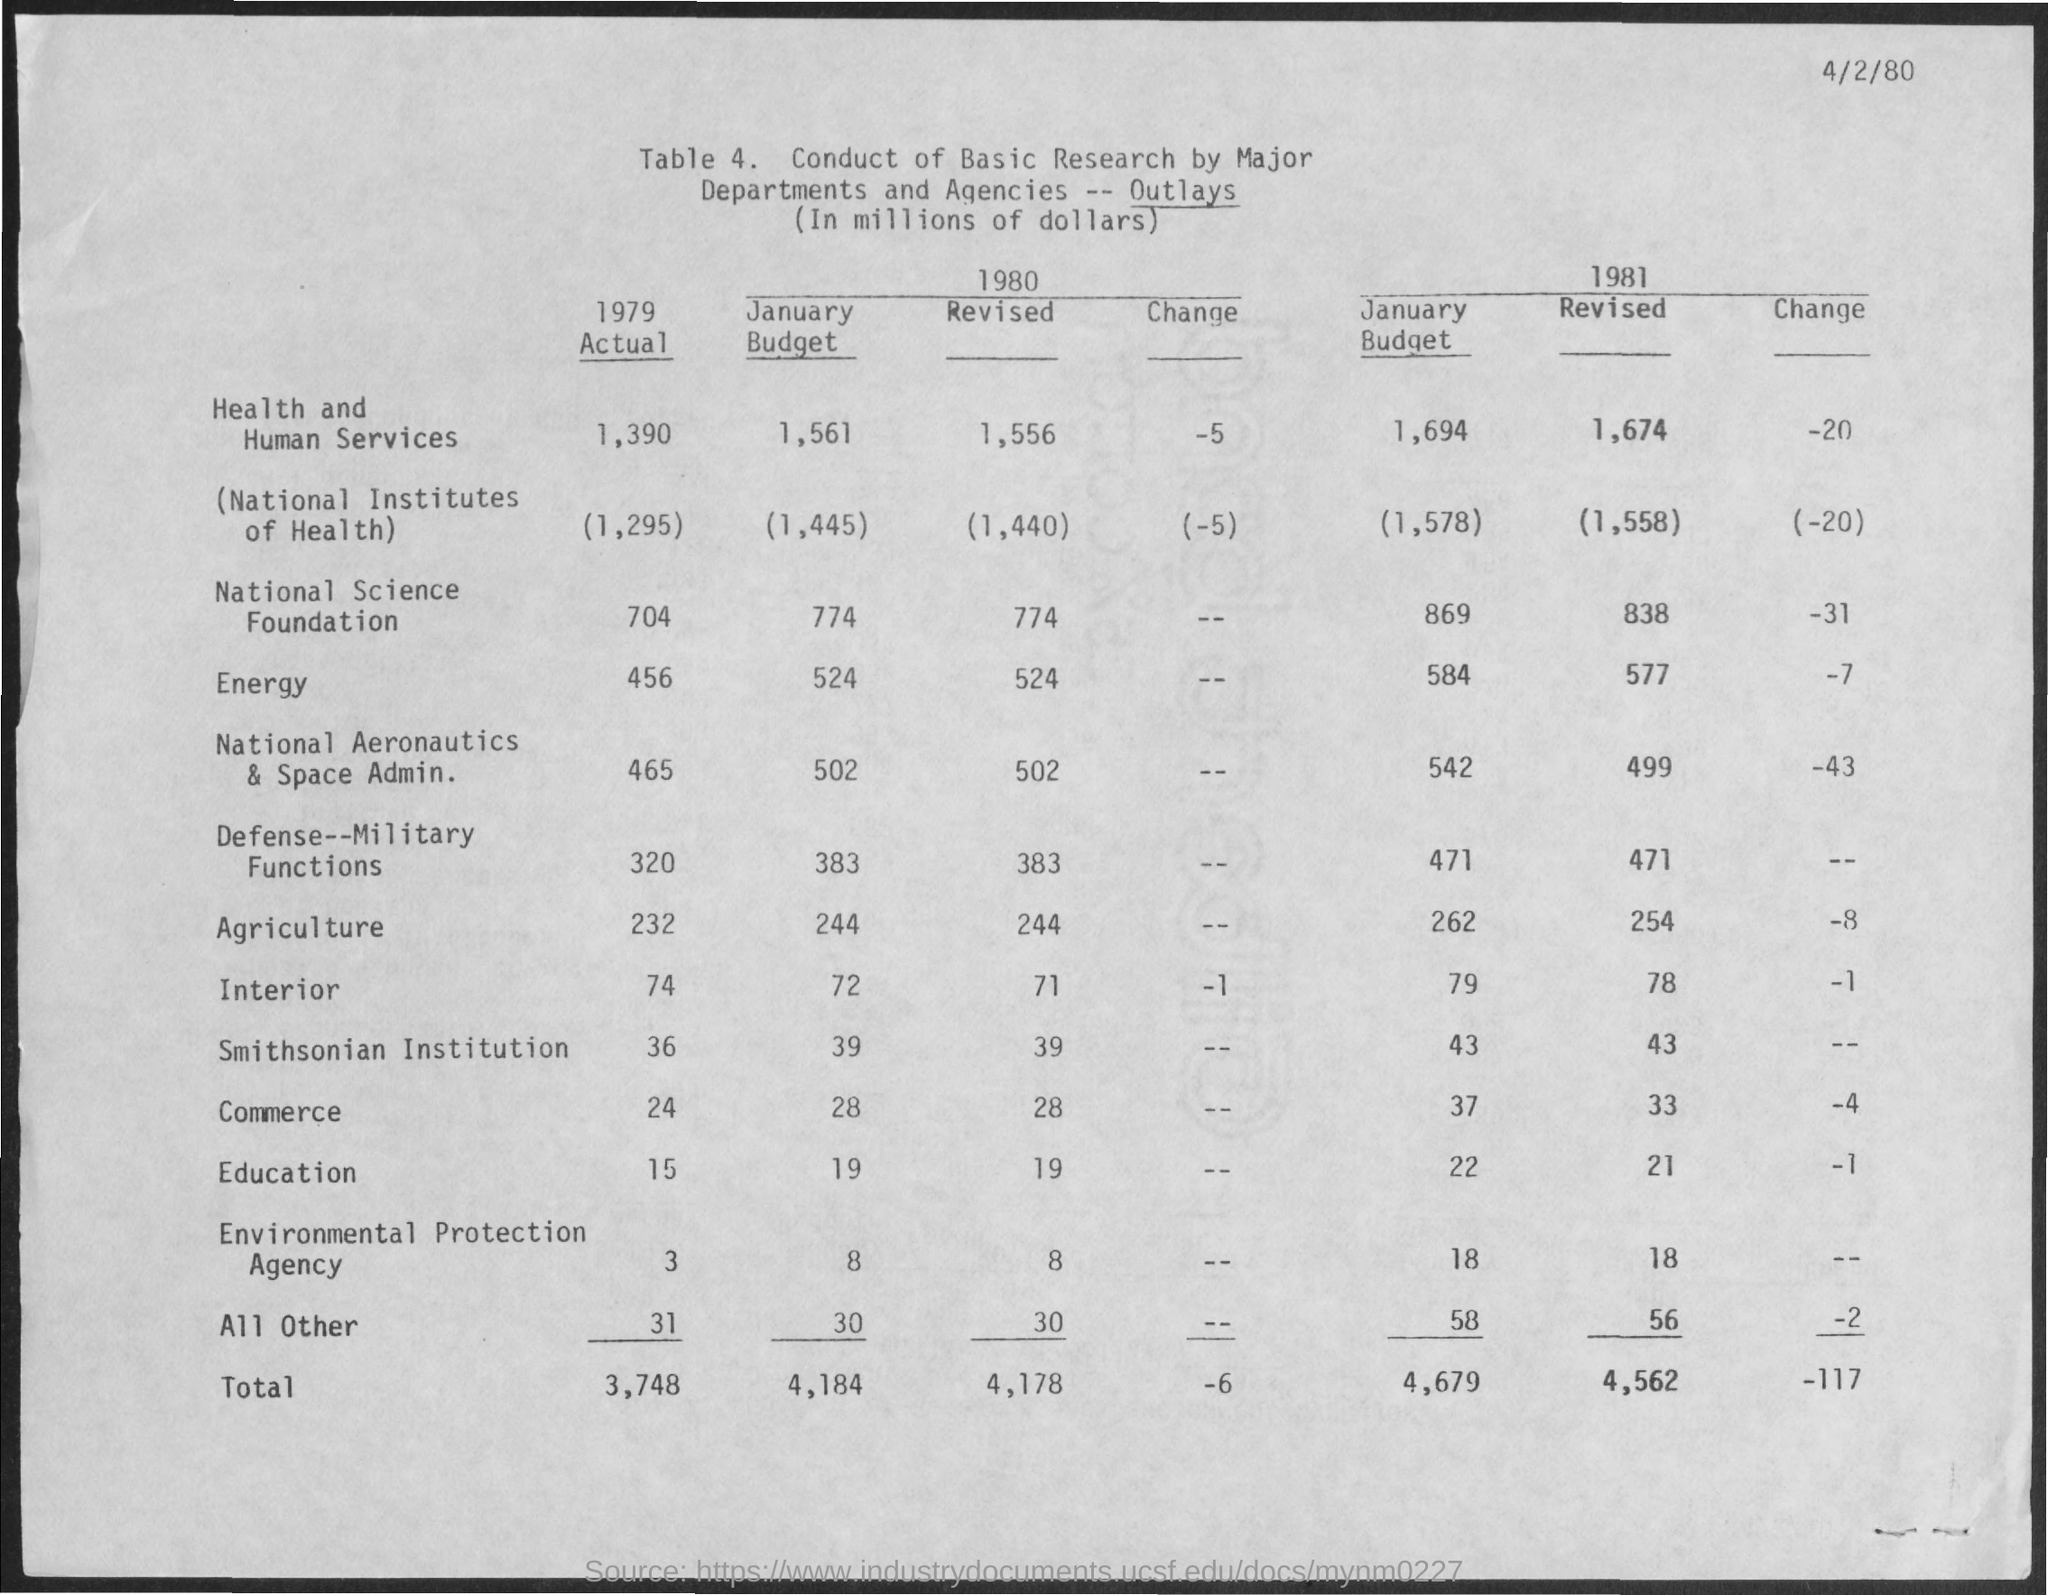What is the date mentioned at the top of the page ?
Your answer should be compact. 4/2/80. What is the january budget for agriculture in 1980 ?
Your answer should be compact. 244. What is the january budget for agriculture in 1981 ?
Offer a very short reply. 262. What is the january budget for interior in 1980 ?
Your answer should be very brief. 72. What is the january budget for interior in 1981 ?
Make the answer very short. 79. What is the january budget for education in 1980 ?
Your answer should be compact. 19. What is the january budget for education in 1981 ?
Provide a short and direct response. 22. What is the total january budget in the year 1980 ?
Offer a very short reply. 4,184. What is the total january budget in the year 1981 ?
Keep it short and to the point. 4,679. 